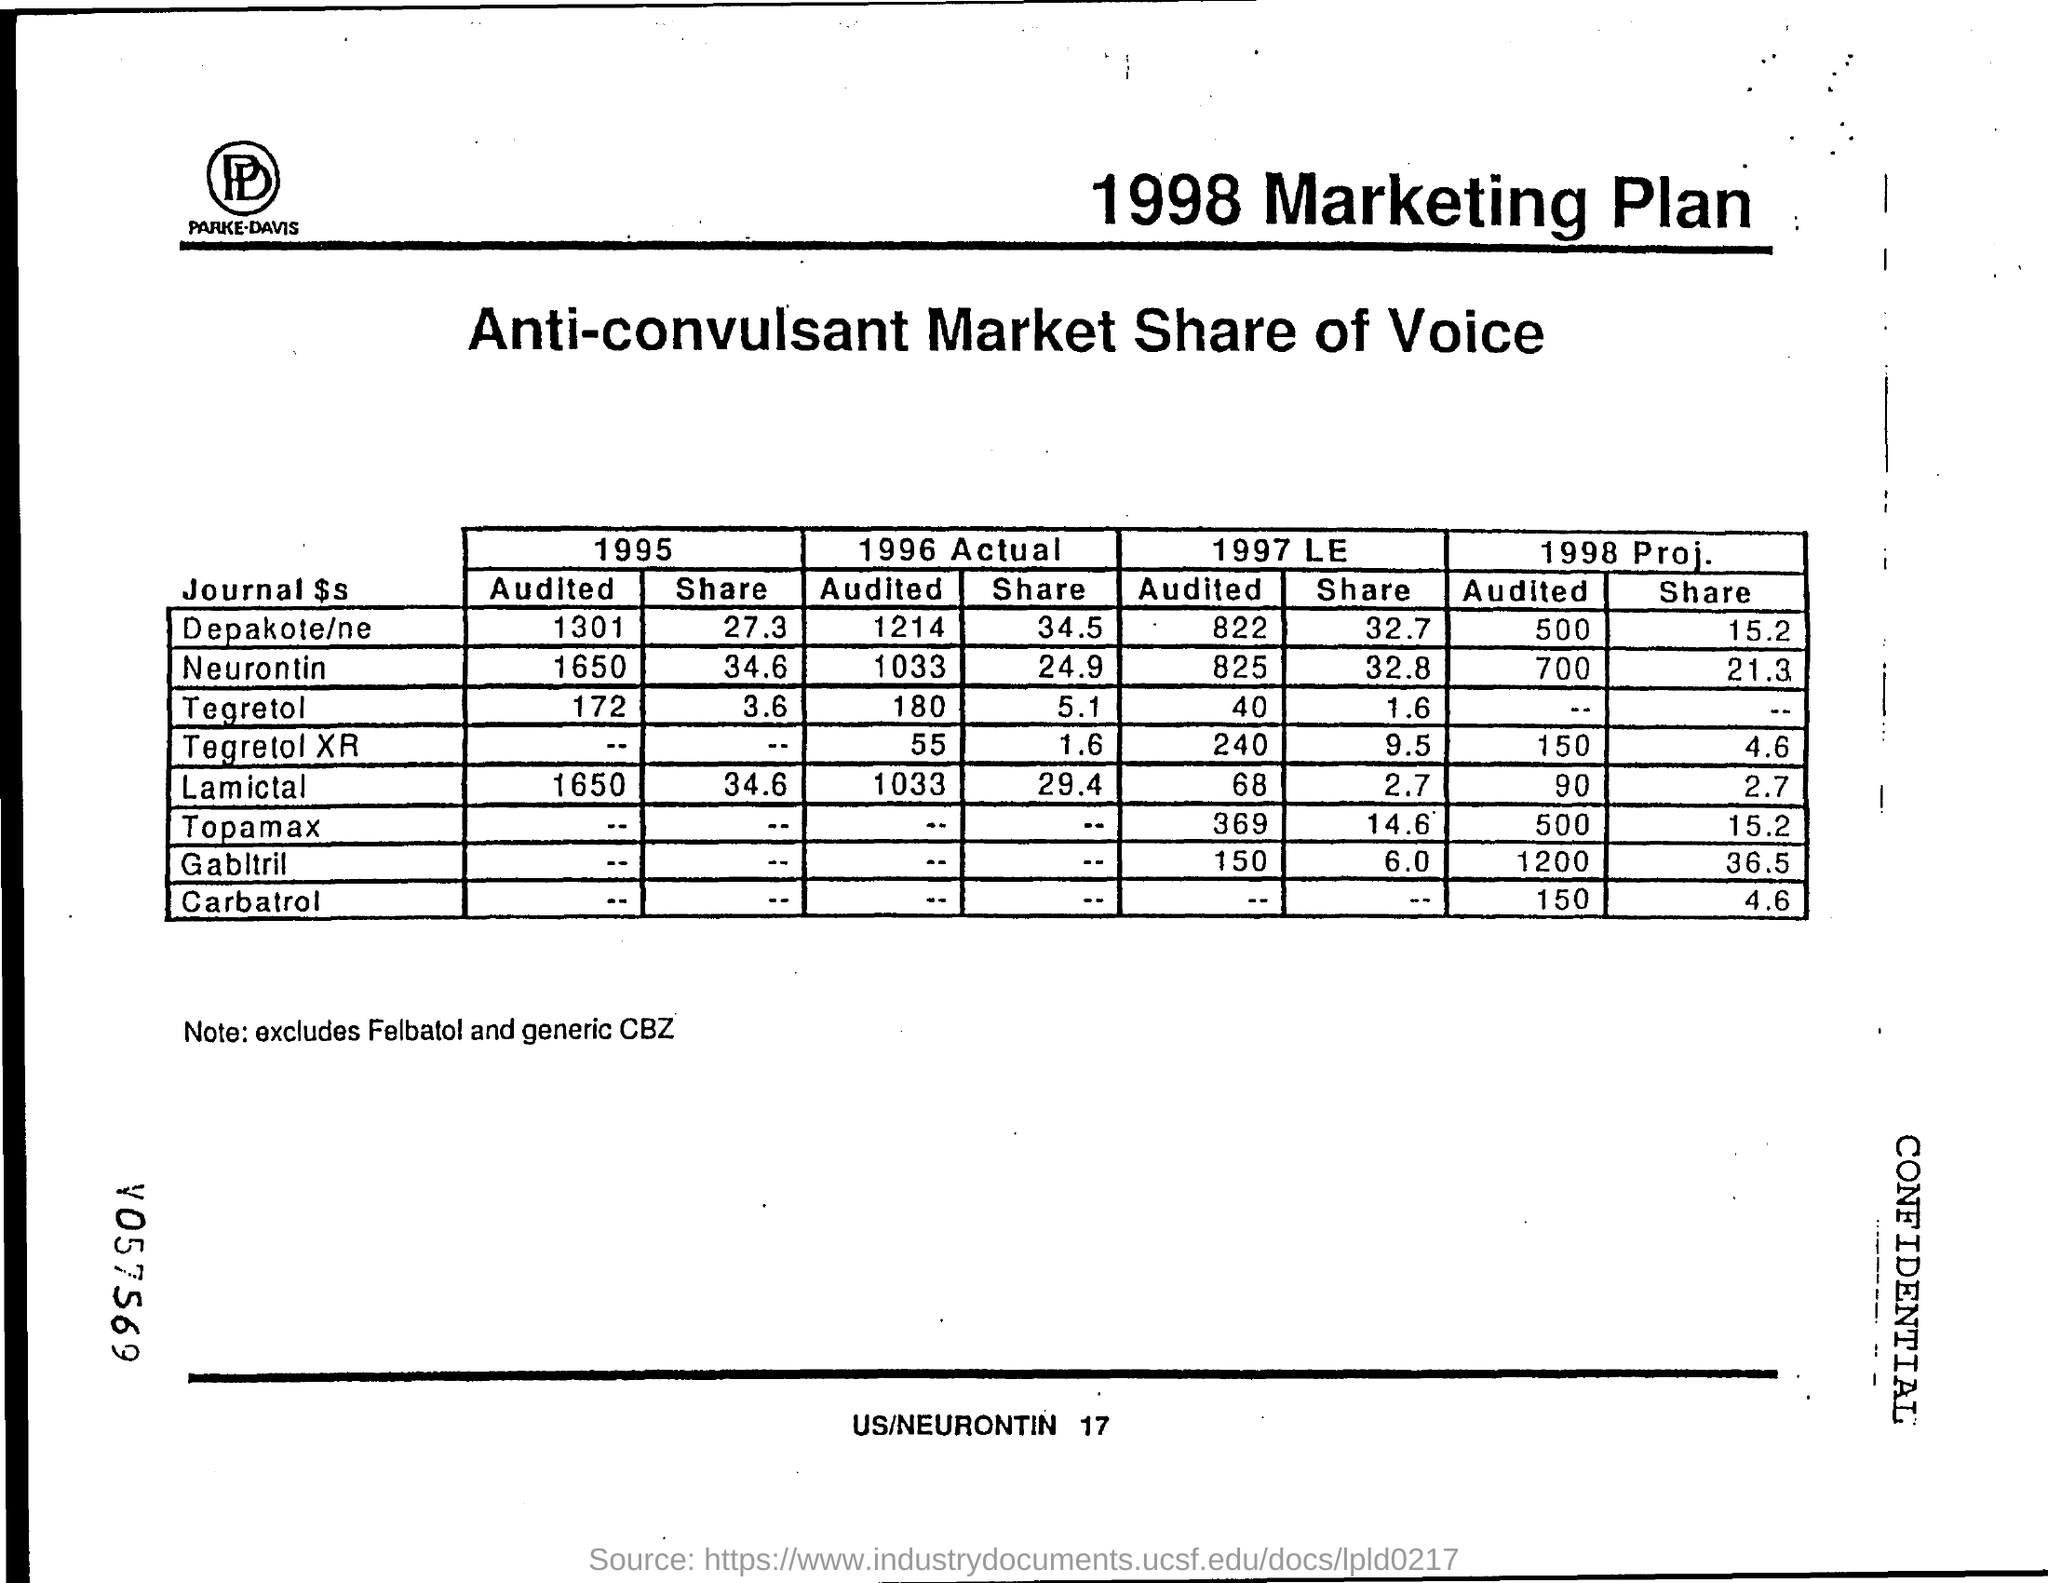Identify some key points in this picture. In 1996, the estimated Depakote/nursing share value was 34.5%. The Neurontin "share" value for 1996 was 24.9. What is the value for Depakote/ne audited in 1996, the actual value being 1214? The audited value for Neurontin in 1996 was 1033. The Lamictal "audited" value for 1995 is 1650. 